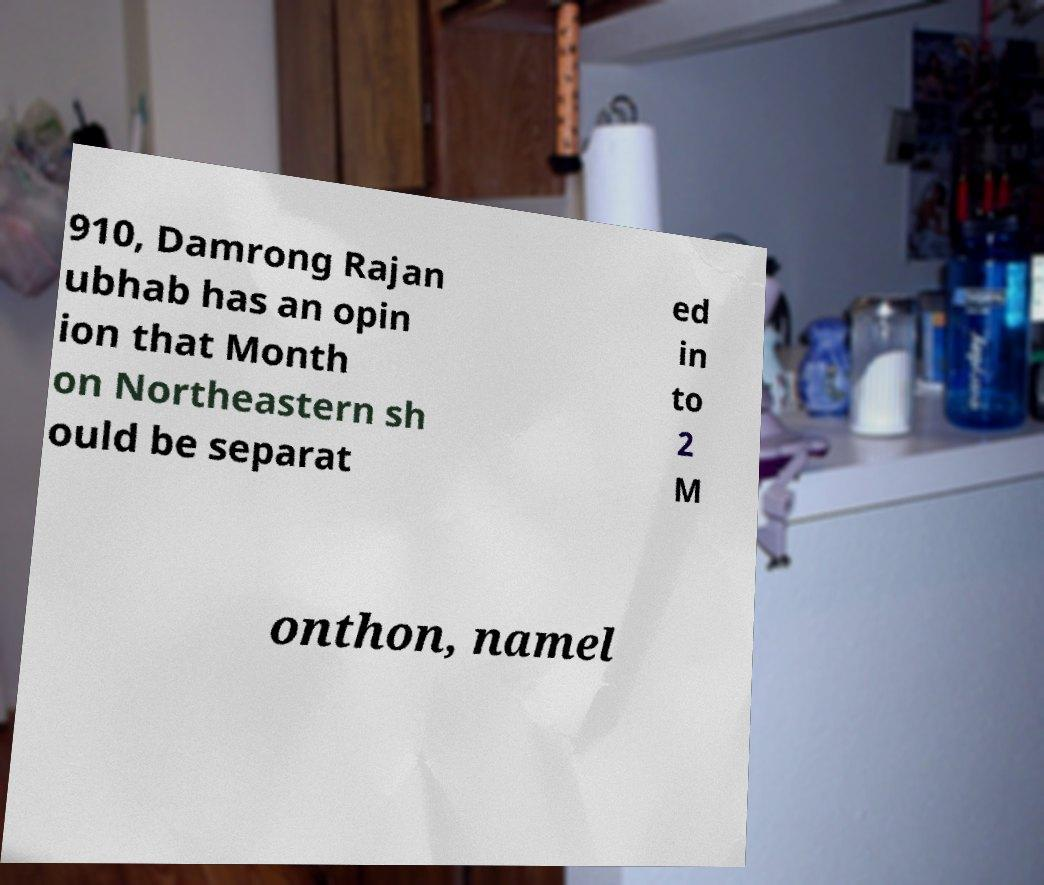What messages or text are displayed in this image? I need them in a readable, typed format. 910, Damrong Rajan ubhab has an opin ion that Month on Northeastern sh ould be separat ed in to 2 M onthon, namel 